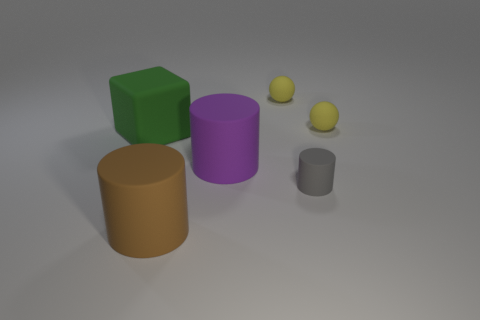Add 1 small red cubes. How many objects exist? 7 Subtract all large cylinders. How many cylinders are left? 1 Subtract 1 cylinders. How many cylinders are left? 2 Add 4 big green matte blocks. How many big green matte blocks are left? 5 Add 2 brown rubber things. How many brown rubber things exist? 3 Subtract 0 red cylinders. How many objects are left? 6 Subtract all balls. How many objects are left? 4 Subtract all green cylinders. Subtract all blue blocks. How many cylinders are left? 3 Subtract all brown blocks. How many purple cylinders are left? 1 Subtract all purple cylinders. Subtract all purple things. How many objects are left? 4 